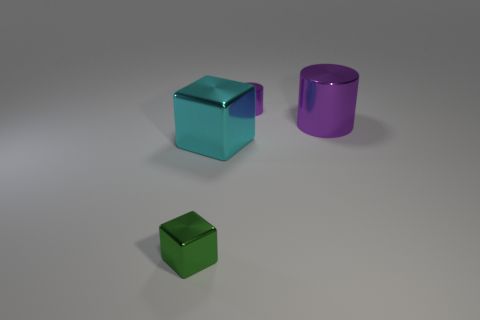Is the shape of the tiny purple metallic thing behind the cyan metallic thing the same as the big shiny thing in front of the large purple object?
Your answer should be compact. No. Is the number of tiny metal things on the left side of the green object less than the number of blocks to the left of the large cyan cube?
Offer a terse response. Yes. There is a thing that is the same color as the small metal cylinder; what shape is it?
Make the answer very short. Cylinder. How many cyan shiny blocks are the same size as the green metallic thing?
Offer a terse response. 0. Is the material of the cyan thing that is behind the tiny green thing the same as the green object?
Ensure brevity in your answer.  Yes. Is there a large metal object?
Make the answer very short. Yes. What is the size of the green object that is made of the same material as the tiny purple cylinder?
Your answer should be compact. Small. Is there a object of the same color as the big cylinder?
Offer a very short reply. Yes. There is a tiny shiny object that is behind the cyan shiny block; does it have the same color as the large object right of the tiny metal cylinder?
Keep it short and to the point. Yes. What is the size of the other cylinder that is the same color as the large metallic cylinder?
Your response must be concise. Small. 